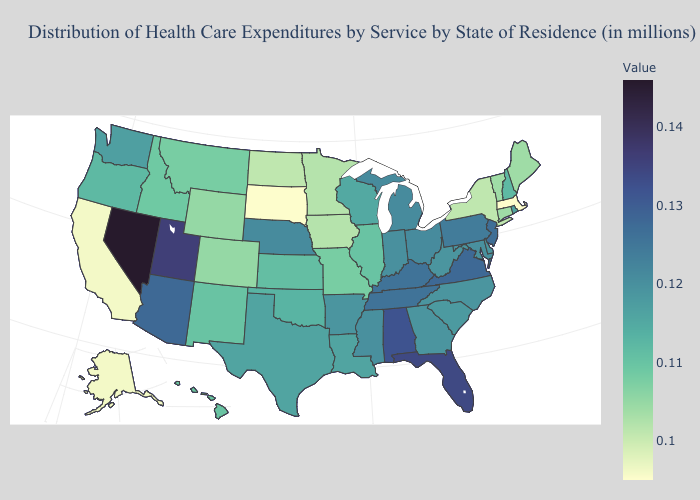Is the legend a continuous bar?
Answer briefly. Yes. Does Georgia have a higher value than South Dakota?
Quick response, please. Yes. Does Massachusetts have the lowest value in the Northeast?
Write a very short answer. Yes. Does the map have missing data?
Write a very short answer. No. Among the states that border Alabama , does Florida have the highest value?
Answer briefly. Yes. 